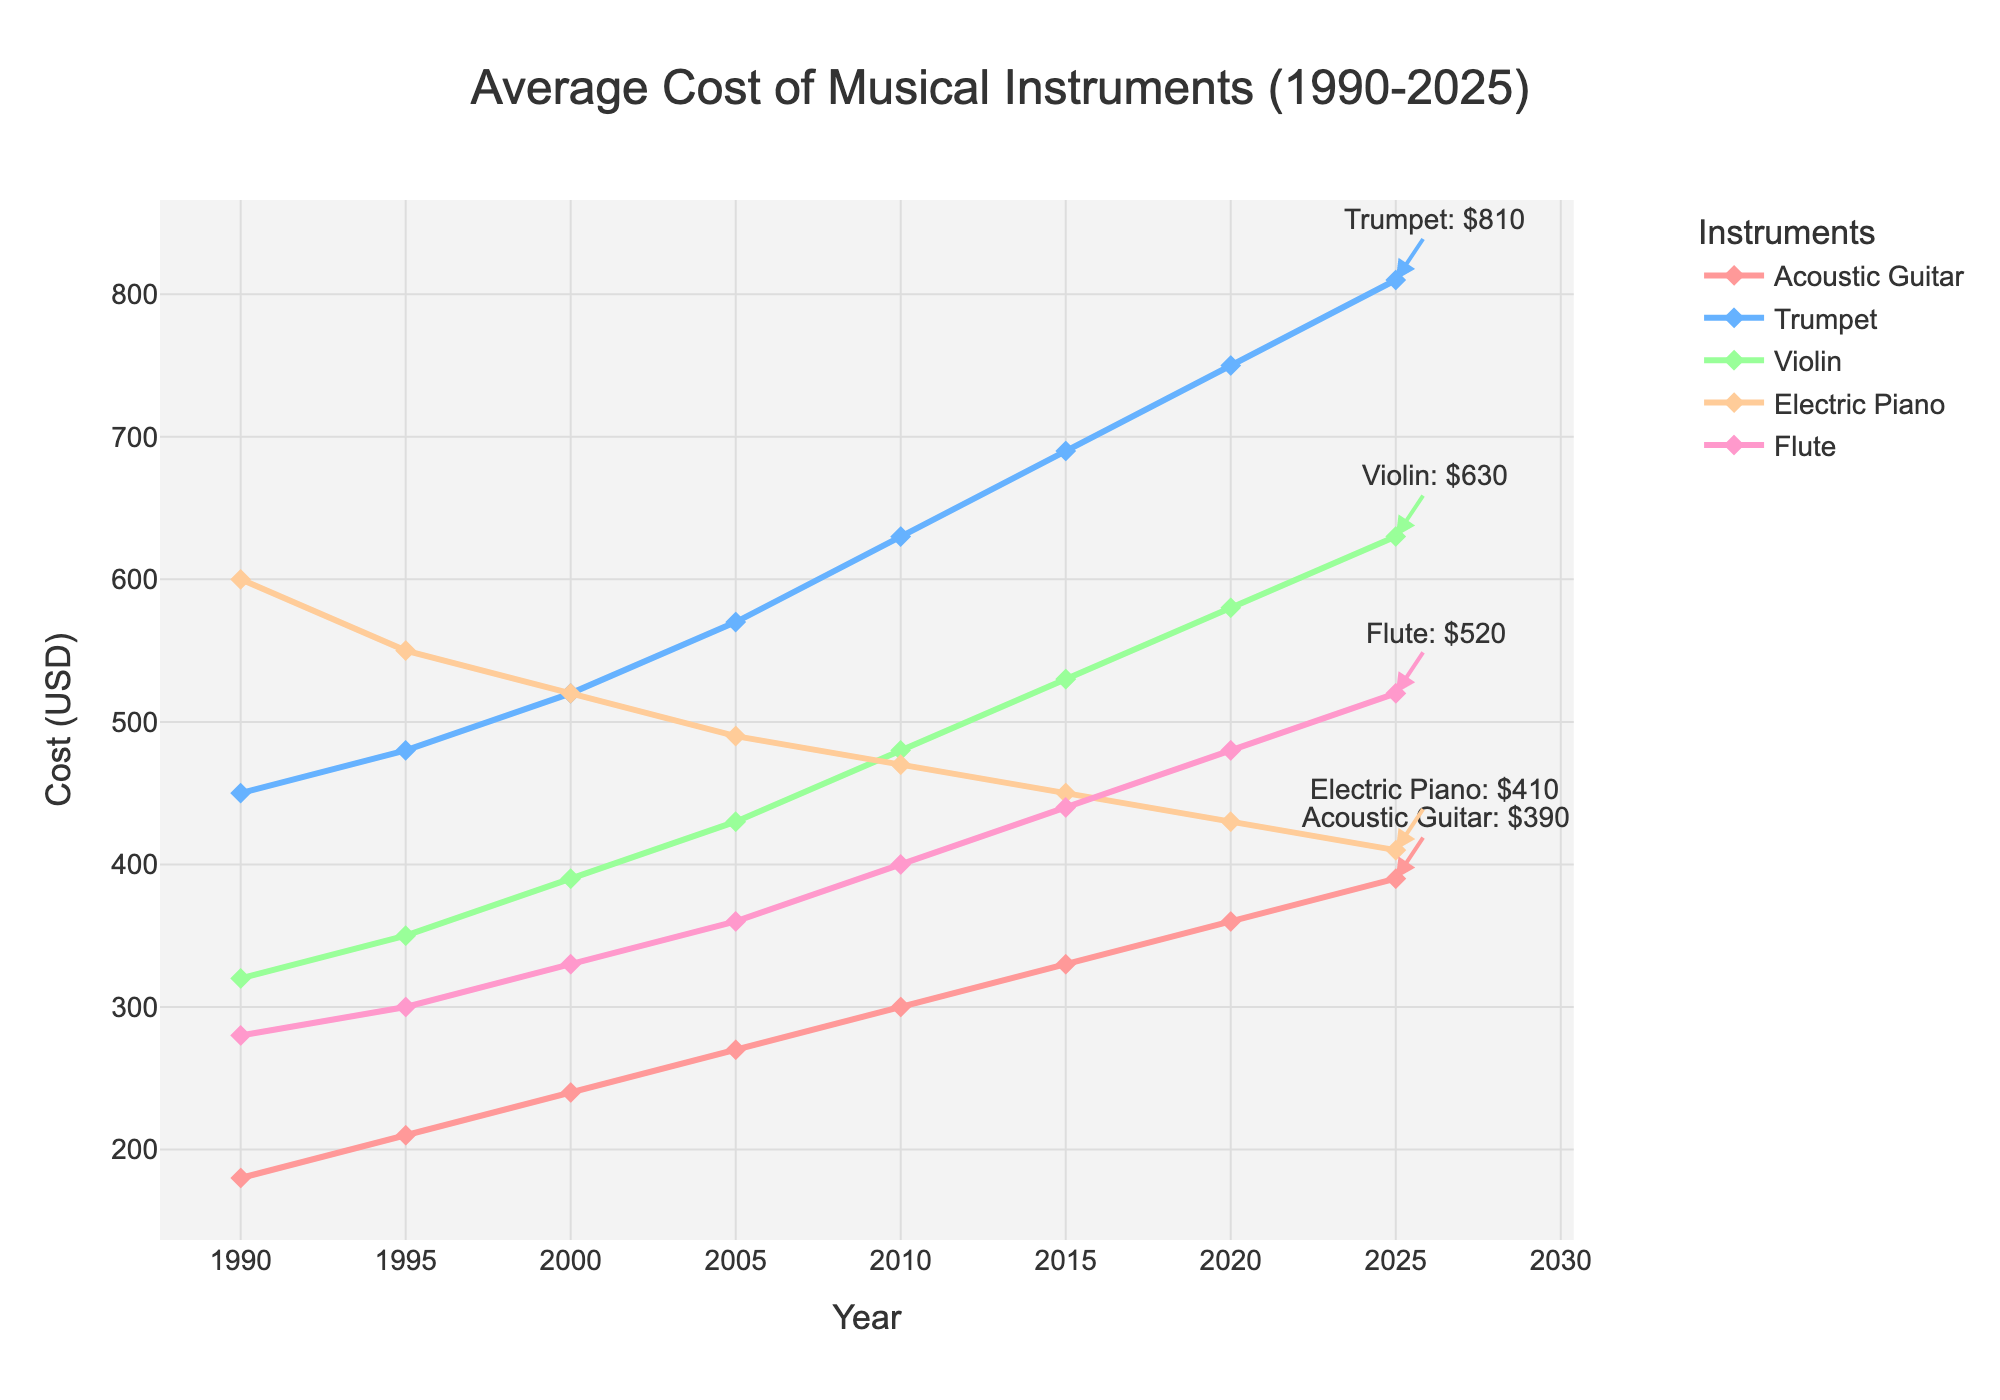What is the average cost of an Acoustic Guitar in 1990 and 2025? To find the average cost, add the costs of 1990 ($180) and 2025 ($390) and then divide by 2: (180 + 390)/2 = 285
Answer: 285 Which musical instrument had the highest increase in cost from 1990 to 2025? To find the highest increase, subtract the 1990 cost from the 2025 cost for each instrument: Acoustic Guitar (390-180), Trumpet (810-450), Violin (630-320), Electric Piano (410-600), Flute (520-280). The Trumpet had the highest increase: 810-450 = 360
Answer: Trumpet How much more does a Violin cost in 2025 compared to 2010? Subtract the 2010 cost of the Violin ($480) from its 2025 cost ($630): 630 - 480 = 150
Answer: 150 Arrange the instruments in descending order of their cost in 2000. Examine the costs in 2000 and arrange them: Electric Piano - $520, Trumpet - $520, Violin - $390, Flute - $330, Acoustic Guitar - $240. So the order is: Electric Piano/Trumpet, Violin, Flute, Acoustic Guitar
Answer: Electric Piano/Trumpet, Violin, Flute, Acoustic Guitar By what percentage did the Electric Piano cost decrease from 1990 to 2025? First calculate the decrease: 600 (1990) - 410 (2025) = 190. Then, calculate the percentage: (190/600) * 100 = 31.67%
Answer: 31.67% Which instrument had the least cost variation from 1990 to 2025? To find the least cost variation, compute the cost difference from 1990 to 2025 for each instrument and find the smallest difference: Acoustic Guitar (210), Trumpet (360), Violin (310), Electric Piano (190), Flute (240). The Electric Piano had the least cost variation: 600 - 410 = 190
Answer: Electric Piano Which year saw the biggest increase in the cost of the Violin? Calculate the year-to-year changes in cost for the Violin and identify the biggest increase: 1990 to 1995 (30), 1995 to 2000 (40), 2000 to 2005 (40), 2005 to 2010 (50), 2010 to 2015 (50), 2015 to 2020 (50), 2020 to 2025 (50). The biggest increase (50) happened multiple times, first in 2005 to 2010
Answer: 2005 to 2010 What is the difference in cost between the most expensive and the cheapest instrument in 2025? Identify the costs in 2025: Acoustic Guitar ($390), Trumpet ($810), Violin ($630), Electric Piano ($410), Flute ($520). The most expensive is the Trumpet at $810 and the cheapest is the Acoustic Guitar at $390. The difference is 810 - 390 = 420
Answer: 420 What was the cost trend for the Flute from 1990 to 2025? Summarize the cost of the Flute over the years: It increased from $280 in 1990 to $520 in 2025. It shows a consistent upward trend and never decreased.
Answer: upward trend Which musical instrument had the most consistent increase in cost over time? Compare the cost increments between each consecutive year for all instruments. The Acoustic Guitar has an equal increment of $30 in each period from 1990 to 2025.
Answer: Acoustic Guitar 